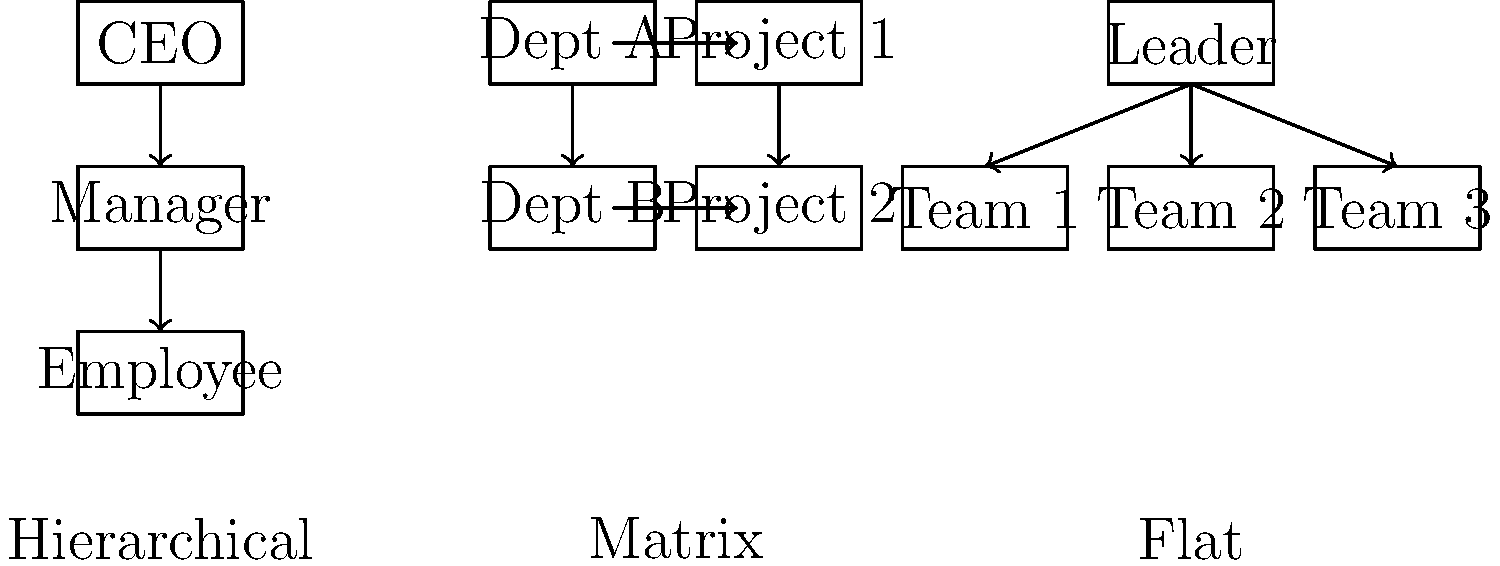As an HR professional, you're tasked with explaining different organizational structures to a new client. Based on the visual comparison provided, which type of organizational chart would be most suitable for a company that wants to promote collaboration between different departments and projects while maintaining clear reporting lines? To determine the most suitable organizational chart for promoting collaboration between departments and projects while maintaining clear reporting lines, let's analyze each structure:

1. Hierarchical Structure:
   - Clear vertical reporting lines
   - Limited horizontal communication
   - Not ideal for cross-departmental collaboration

2. Flat Structure:
   - Minimal hierarchy
   - Good for small organizations
   - May lack clear reporting lines for larger companies

3. Matrix Structure:
   - Combines vertical and horizontal reporting lines
   - Employees report to both functional and project managers
   - Facilitates cross-departmental collaboration
   - Maintains clear reporting structure

The Matrix structure best meets the requirements because:
a) It allows for collaboration between different departments (vertical lines) and projects (horizontal lines).
b) It maintains clear reporting lines to both functional managers and project managers.
c) It's designed to balance the need for specialization within departments and the flexibility required for project-based work.

This structure is particularly effective for companies that work on multiple projects simultaneously and require input from various specialized departments.
Answer: Matrix structure 